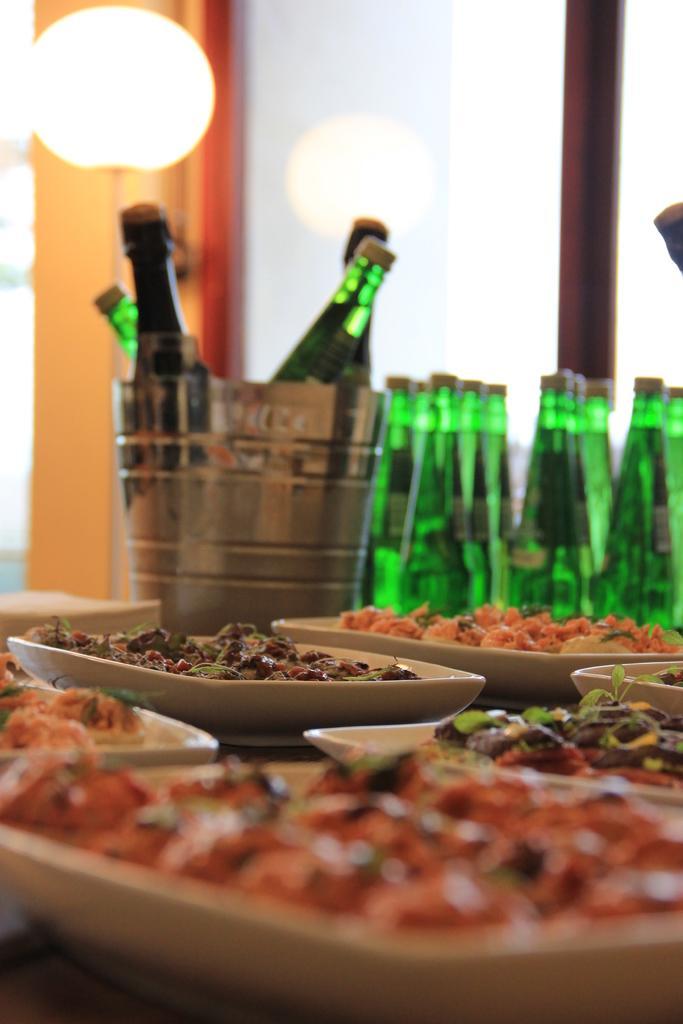Can you describe this image briefly? In this picture there are group of bottles, plates and some food on the table. In the background there is a light. 